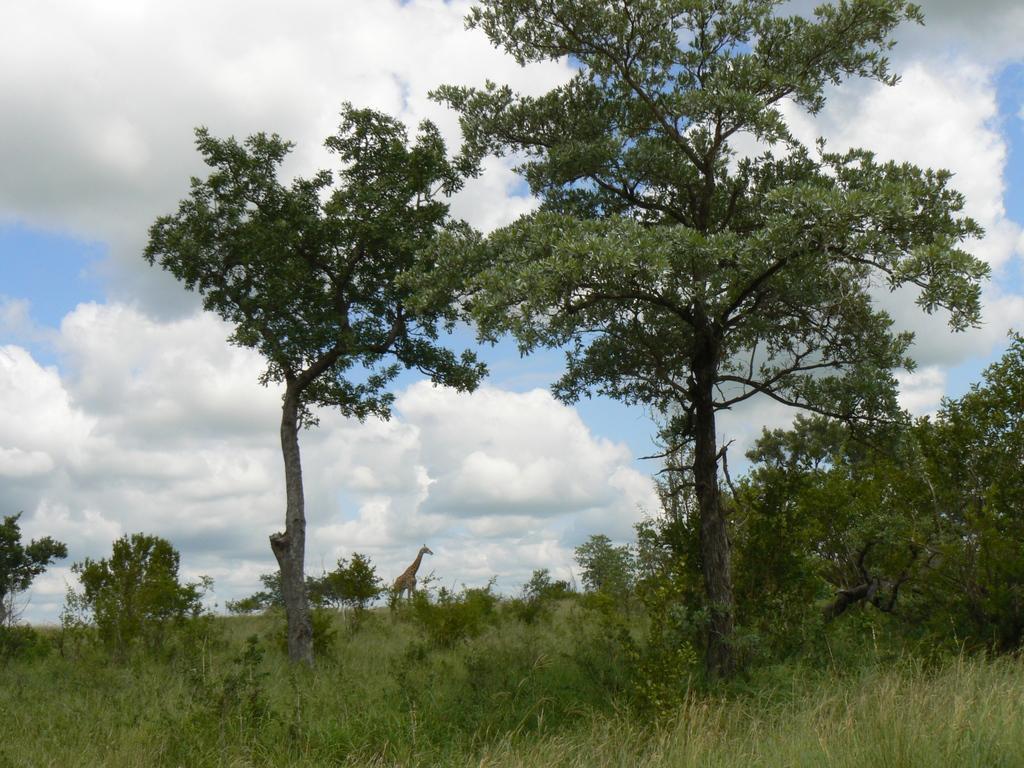How would you summarize this image in a sentence or two? In the image there are trees and plants on the grass land, in the background there is a giraffe standing in the middle and above the sky is filled with clouds. 